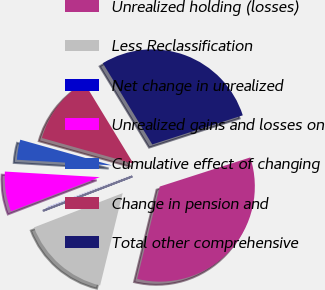Convert chart to OTSL. <chart><loc_0><loc_0><loc_500><loc_500><pie_chart><fcel>Unrealized holding (losses)<fcel>Less Reclassification<fcel>Net change in unrealized<fcel>Unrealized gains and losses on<fcel>Cumulative effect of changing<fcel>Change in pension and<fcel>Total other comprehensive<nl><fcel>33.77%<fcel>15.32%<fcel>0.03%<fcel>6.78%<fcel>3.41%<fcel>11.95%<fcel>28.75%<nl></chart> 